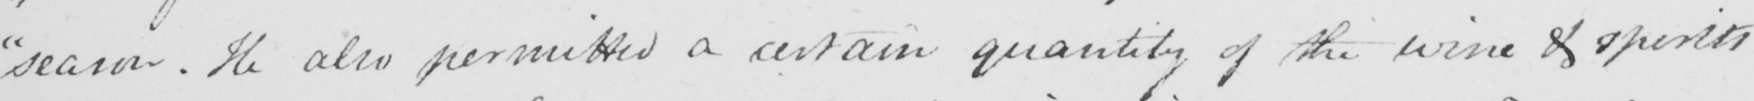What does this handwritten line say? " season . He also permitted a certain quantity of the wine & spirits 